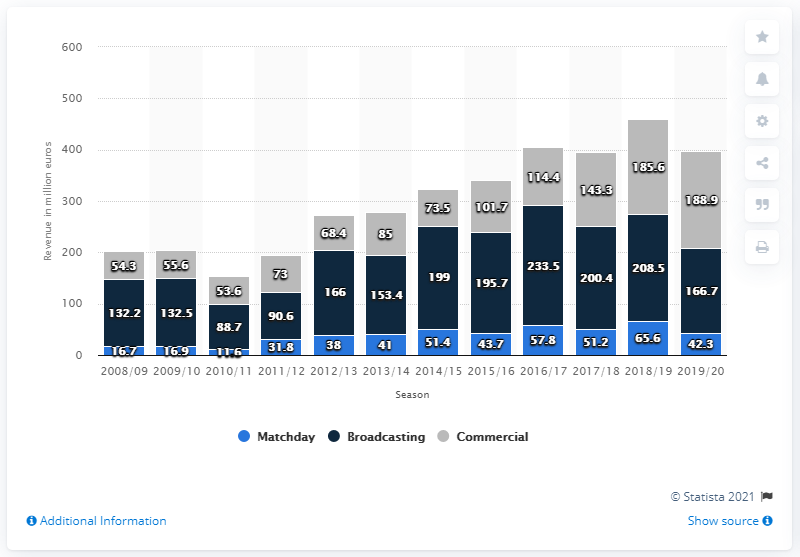Identify some key points in this picture. Juventus earned a total of 208.5 million Euros in 2018/2019 from domestic and international competition broadcasting revenues. Juventus FC earned 185.6 million USD from sponsorships and merchandising in the 2018/2019 fiscal year. 